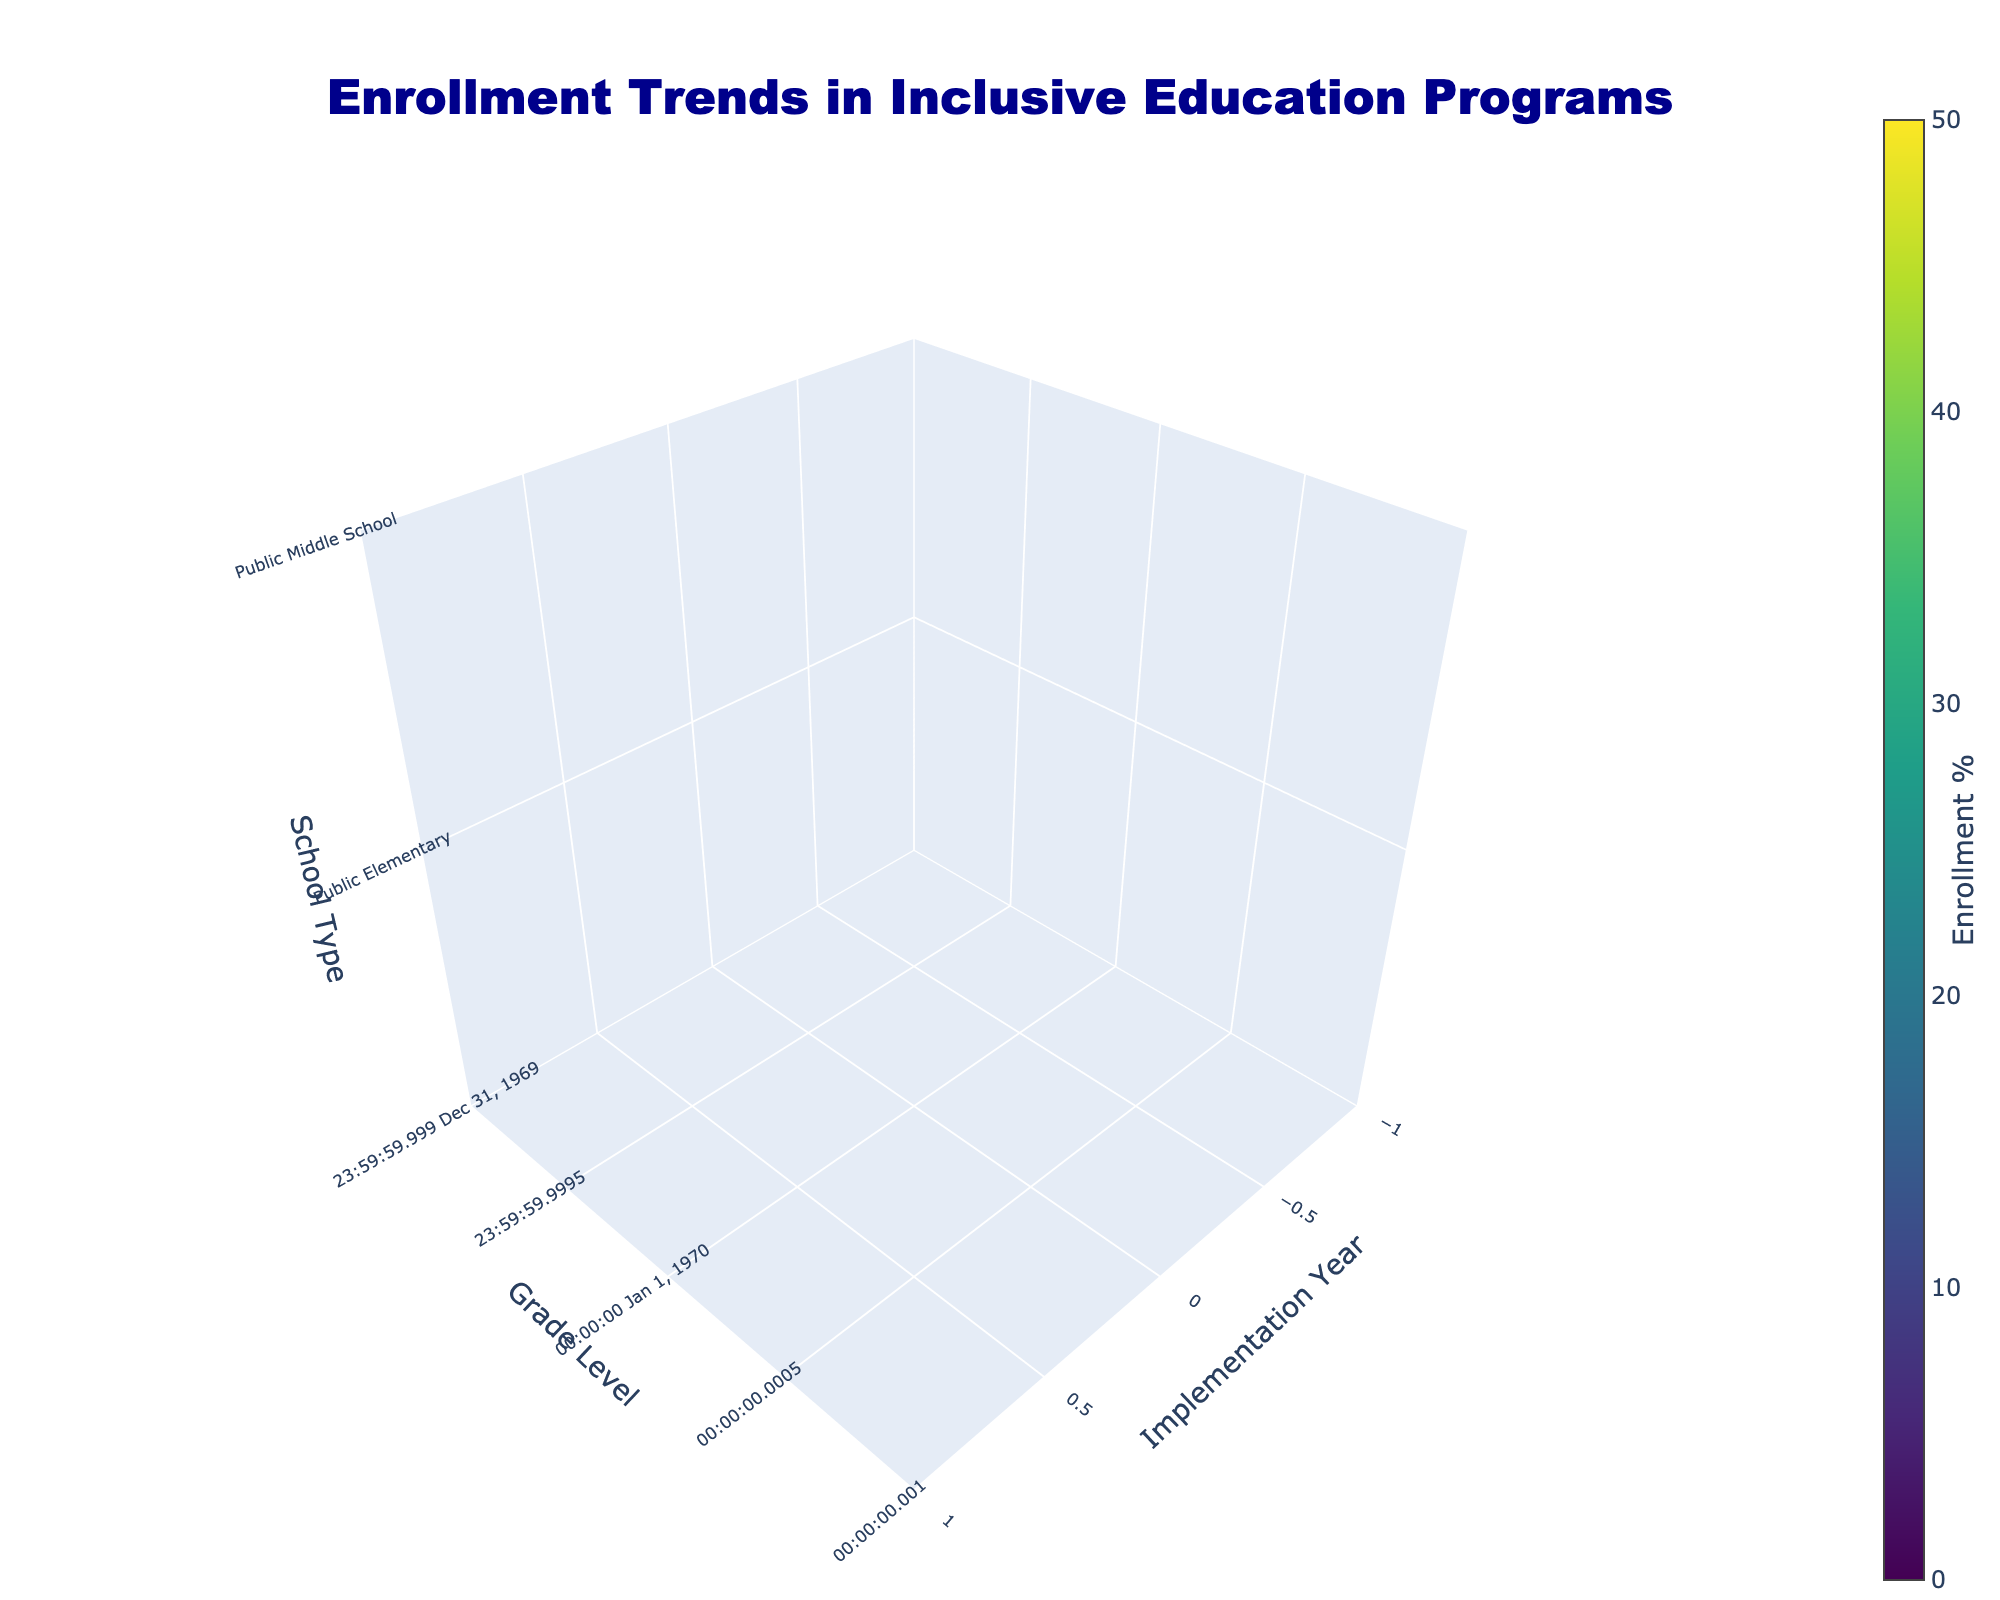What is the title of the plot? The title of the plot is displayed above the 3D volume plot. It reads “Enrollment Trends in Inclusive Education Programs.”
Answer: Enrollment Trends in Inclusive Education Programs What does the color scale represent in the plot? The color scale in the plot represents the enrollment percentage, which ranges from low to high. The color changes according to the value of the enrollment percentage with a labeled color bar.
Answer: Enrollment Percentage Which grade level and implementation year show the highest enrollment percentage for Charter Elementary schools? To find this, focus on the Charter Elementary schools and locate the grade level and year with the highest intensity in the color scale. The highest enrollment percentage for Charter Elementary is for grade 3-5 in 2021, represented by the highest value on the color scale.
Answer: Grade 3-5, 2021 Compare the enrollment percentage of Public Elementary schools’ grade K-2 in 2015 and 2021. Which year shows higher enrollment? Locate the values for Public Elementary schools of grade K-2 for the years 2015 and 2021. Compare these values based on their positions in the color scale. The color for 2021 is more intense than that for 2015, indicating a higher percentage in 2021.
Answer: 2021 What is the difference in the enrollment percentage between Public Middle School in 2018 and 2021? Check the values for Public Middle School in 2018 and 2021 on the color scale. For 2018, the percentage is 25%, and for 2021, it's 33%. The difference can be calculated as 33% - 25%.
Answer: 8% Which school type and grade level have the lowest enrollment percentage in 2015? Scan through the color scale values across different school types and grade levels for the year 2015. Public High School grade 11-12 has the lowest percentage, represented by the least intense color.
Answer: Public High School, grade 11-12 What trend can be observed in enrollment percentages for Private K-12 schools from 2015 to 2021? Observe the color intensity changes for Private K-12 schools across the years 2015, 2018, and 2021. The color becomes more intense over time, indicating an increasing trend in enrollment percentages from 2015 to 2021.
Answer: Increasing trend Compare the enrollment percentage trends of Public and Charter Middle Schools between 2015 and 2021. Look at the changes in the color scale for both Public and Charter Middle Schools from 2015 to 2021. Both show an increase, but Charter Middle Schools have a more significant change in color intensity, indicating a higher increase in enrollment percentage compared to Public Middle Schools.
Answer: Charter Middle Schools show a higher increase What are the isomin and isomax values in the plot? These values are specified in the volume plot settings to define the range of color intensity. The isomin is set to 0, and the isomax is set to 50, covering the range of enrollment percentages in the plot.
Answer: 0 for isomin and 50 for isomax What is the enrollment percentage for Charter Elementary schools in grade K-2 in 2018? Find the Charter Elementary schools and locate the grade K-2 for the year 2018. The specific color intensity represents the enrollment percentage, which is 30%.
Answer: 30% 